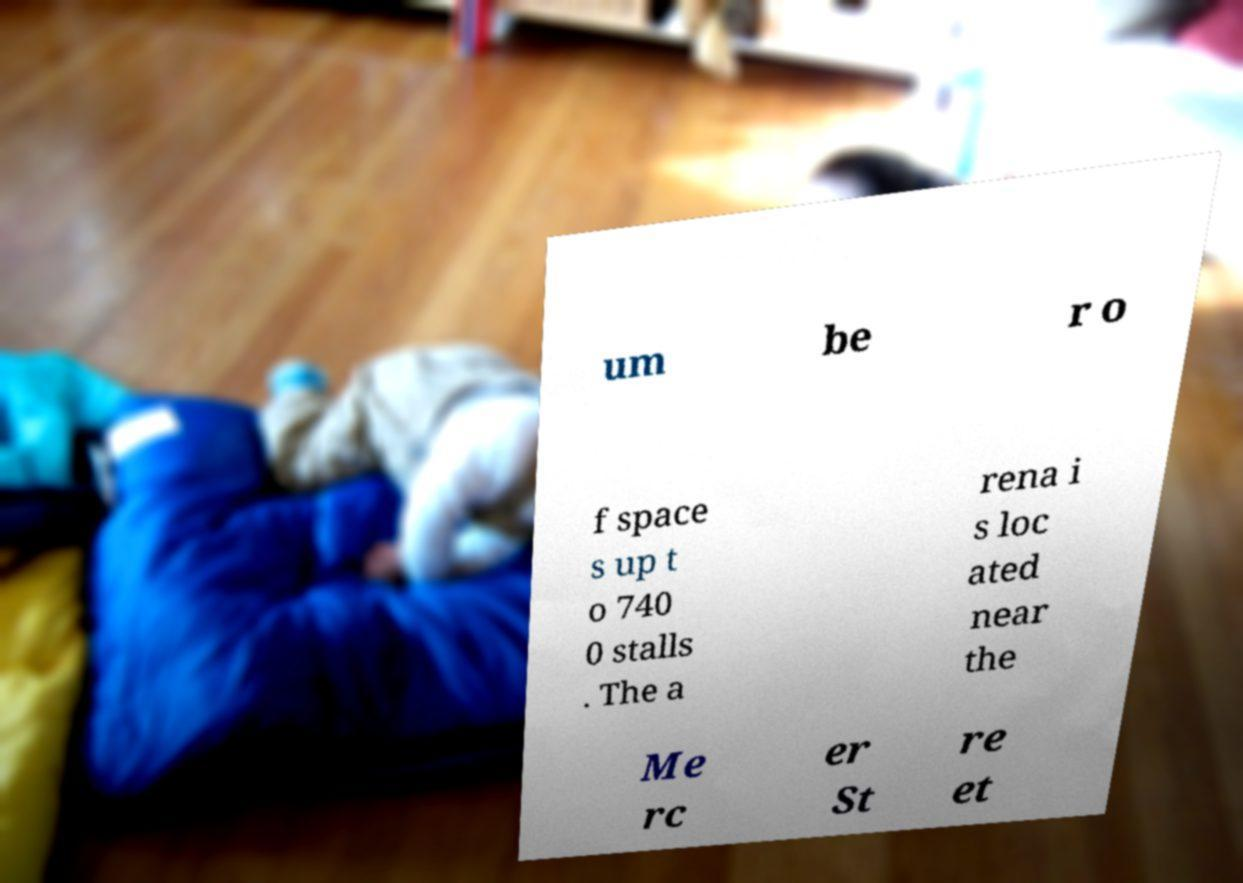Please identify and transcribe the text found in this image. um be r o f space s up t o 740 0 stalls . The a rena i s loc ated near the Me rc er St re et 